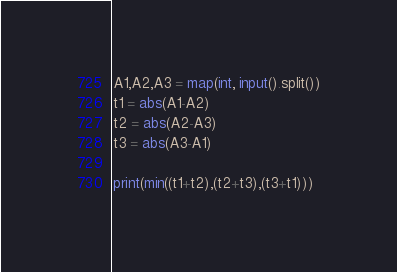Convert code to text. <code><loc_0><loc_0><loc_500><loc_500><_Python_>A1,A2,A3 = map(int, input().split())
t1 = abs(A1-A2)
t2 = abs(A2-A3)
t3 = abs(A3-A1)

print(min((t1+t2),(t2+t3),(t3+t1)))</code> 